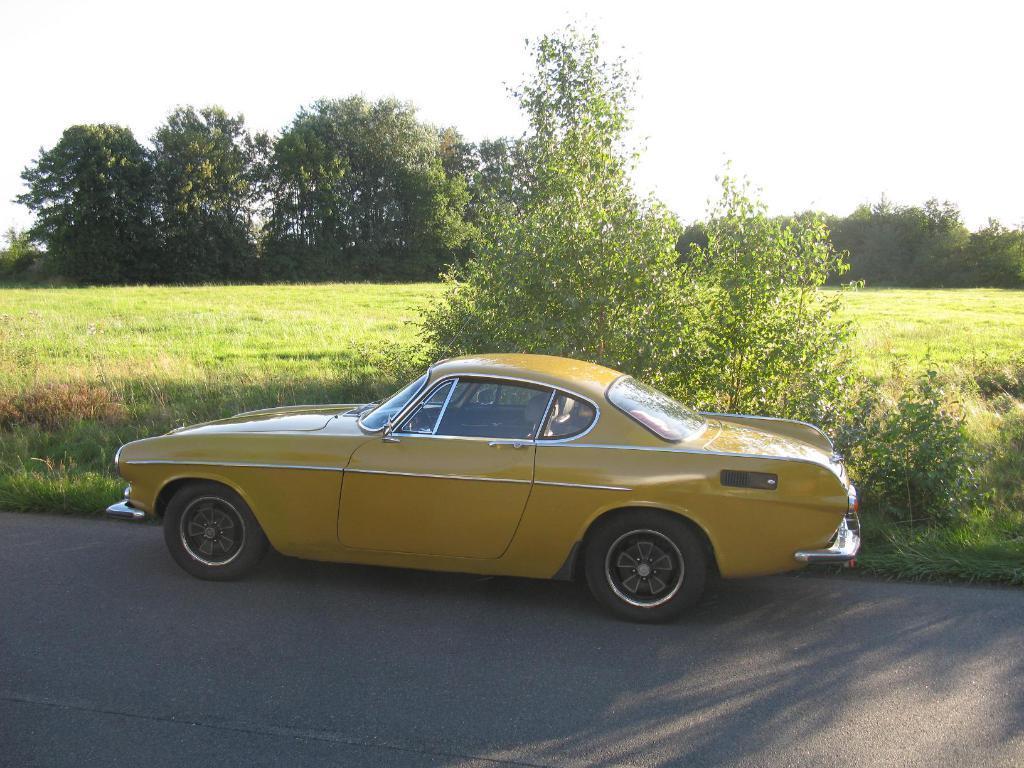In one or two sentences, can you explain what this image depicts? In this picture we can observe yellow color car on the road. We can observe some plants and grass on the ground. In the background there are trees and a sky. 